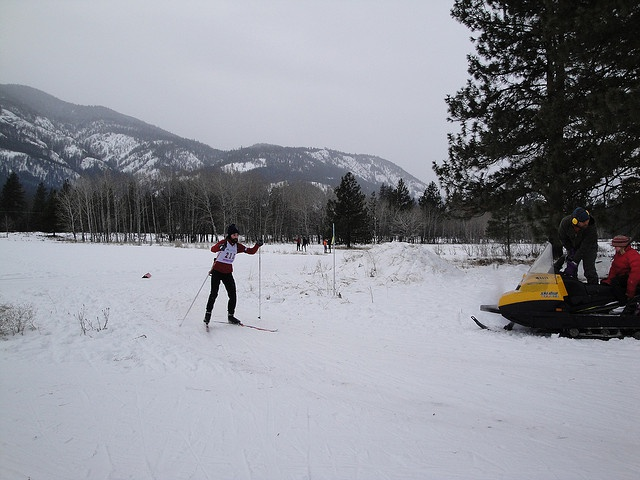Describe the objects in this image and their specific colors. I can see people in darkgray, black, gray, and maroon tones, people in darkgray, black, maroon, and gray tones, people in darkgray, maroon, black, and brown tones, skis in darkgray, gray, black, and lightgray tones, and people in darkgray, black, lightgray, and gray tones in this image. 